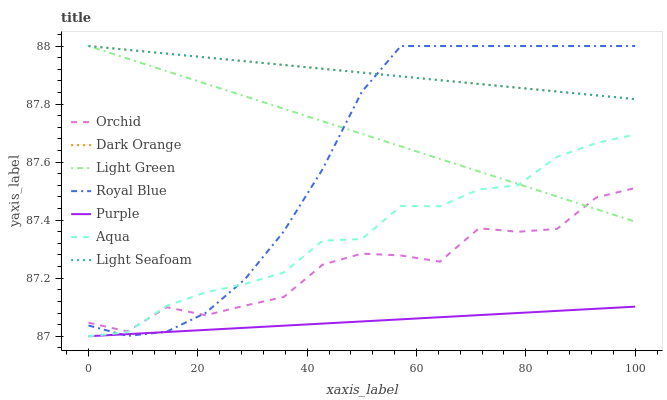Does Purple have the minimum area under the curve?
Answer yes or no. Yes. Does Dark Orange have the maximum area under the curve?
Answer yes or no. Yes. Does Aqua have the minimum area under the curve?
Answer yes or no. No. Does Aqua have the maximum area under the curve?
Answer yes or no. No. Is Light Seafoam the smoothest?
Answer yes or no. Yes. Is Orchid the roughest?
Answer yes or no. Yes. Is Purple the smoothest?
Answer yes or no. No. Is Purple the roughest?
Answer yes or no. No. Does Purple have the lowest value?
Answer yes or no. Yes. Does Royal Blue have the lowest value?
Answer yes or no. No. Does Light Seafoam have the highest value?
Answer yes or no. Yes. Does Aqua have the highest value?
Answer yes or no. No. Is Purple less than Light Green?
Answer yes or no. Yes. Is Light Seafoam greater than Orchid?
Answer yes or no. Yes. Does Royal Blue intersect Purple?
Answer yes or no. Yes. Is Royal Blue less than Purple?
Answer yes or no. No. Is Royal Blue greater than Purple?
Answer yes or no. No. Does Purple intersect Light Green?
Answer yes or no. No. 